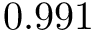<formula> <loc_0><loc_0><loc_500><loc_500>0 . 9 9 1</formula> 